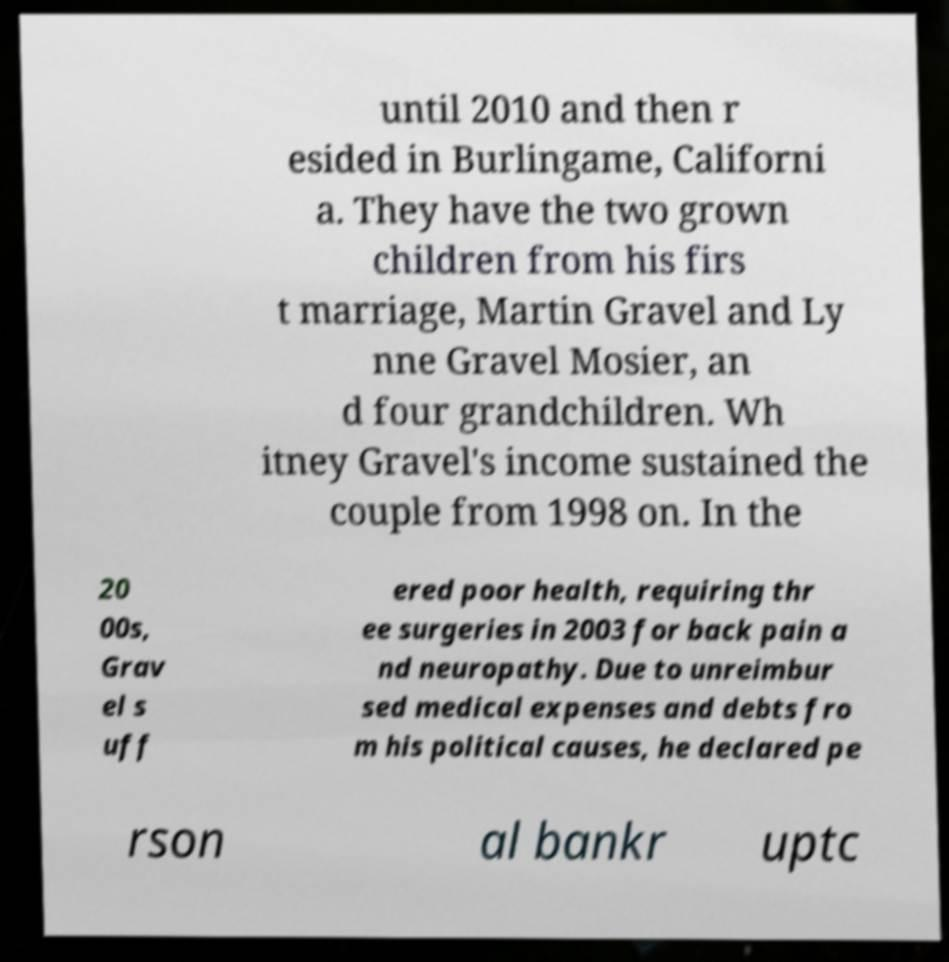Could you assist in decoding the text presented in this image and type it out clearly? until 2010 and then r esided in Burlingame, Californi a. They have the two grown children from his firs t marriage, Martin Gravel and Ly nne Gravel Mosier, an d four grandchildren. Wh itney Gravel's income sustained the couple from 1998 on. In the 20 00s, Grav el s uff ered poor health, requiring thr ee surgeries in 2003 for back pain a nd neuropathy. Due to unreimbur sed medical expenses and debts fro m his political causes, he declared pe rson al bankr uptc 